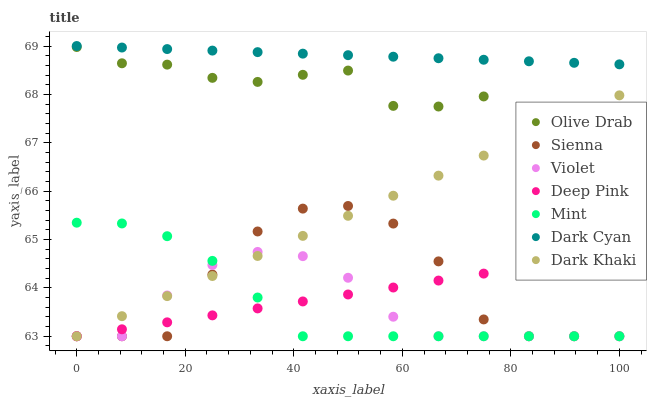Does Violet have the minimum area under the curve?
Answer yes or no. Yes. Does Dark Cyan have the maximum area under the curve?
Answer yes or no. Yes. Does Deep Pink have the minimum area under the curve?
Answer yes or no. No. Does Deep Pink have the maximum area under the curve?
Answer yes or no. No. Is Deep Pink the smoothest?
Answer yes or no. Yes. Is Sienna the roughest?
Answer yes or no. Yes. Is Sienna the smoothest?
Answer yes or no. No. Is Deep Pink the roughest?
Answer yes or no. No. Does Dark Khaki have the lowest value?
Answer yes or no. Yes. Does Dark Cyan have the lowest value?
Answer yes or no. No. Does Dark Cyan have the highest value?
Answer yes or no. Yes. Does Sienna have the highest value?
Answer yes or no. No. Is Dark Khaki less than Dark Cyan?
Answer yes or no. Yes. Is Olive Drab greater than Violet?
Answer yes or no. Yes. Does Violet intersect Mint?
Answer yes or no. Yes. Is Violet less than Mint?
Answer yes or no. No. Is Violet greater than Mint?
Answer yes or no. No. Does Dark Khaki intersect Dark Cyan?
Answer yes or no. No. 